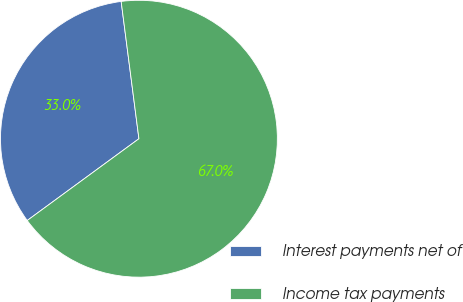Convert chart to OTSL. <chart><loc_0><loc_0><loc_500><loc_500><pie_chart><fcel>Interest payments net of<fcel>Income tax payments<nl><fcel>33.01%<fcel>66.99%<nl></chart> 